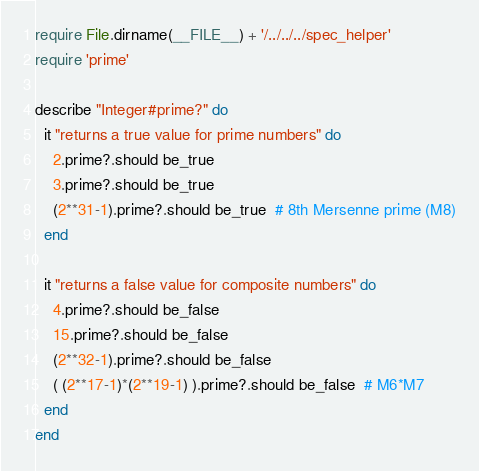Convert code to text. <code><loc_0><loc_0><loc_500><loc_500><_Ruby_>require File.dirname(__FILE__) + '/../../../spec_helper'
require 'prime'

describe "Integer#prime?" do
  it "returns a true value for prime numbers" do
    2.prime?.should be_true
    3.prime?.should be_true
    (2**31-1).prime?.should be_true  # 8th Mersenne prime (M8)
  end

  it "returns a false value for composite numbers" do
    4.prime?.should be_false
    15.prime?.should be_false
    (2**32-1).prime?.should be_false
    ( (2**17-1)*(2**19-1) ).prime?.should be_false  # M6*M7
  end
end
</code> 